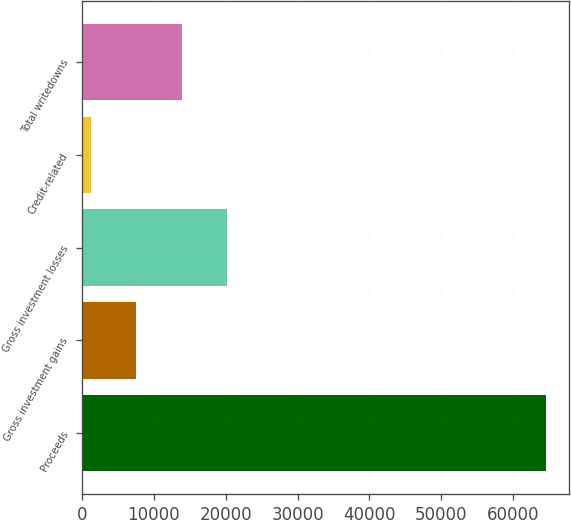Convert chart. <chart><loc_0><loc_0><loc_500><loc_500><bar_chart><fcel>Proceeds<fcel>Gross investment gains<fcel>Gross investment losses<fcel>Credit-related<fcel>Total writedowns<nl><fcel>64602<fcel>7565.4<fcel>20240.2<fcel>1228<fcel>13902.8<nl></chart> 